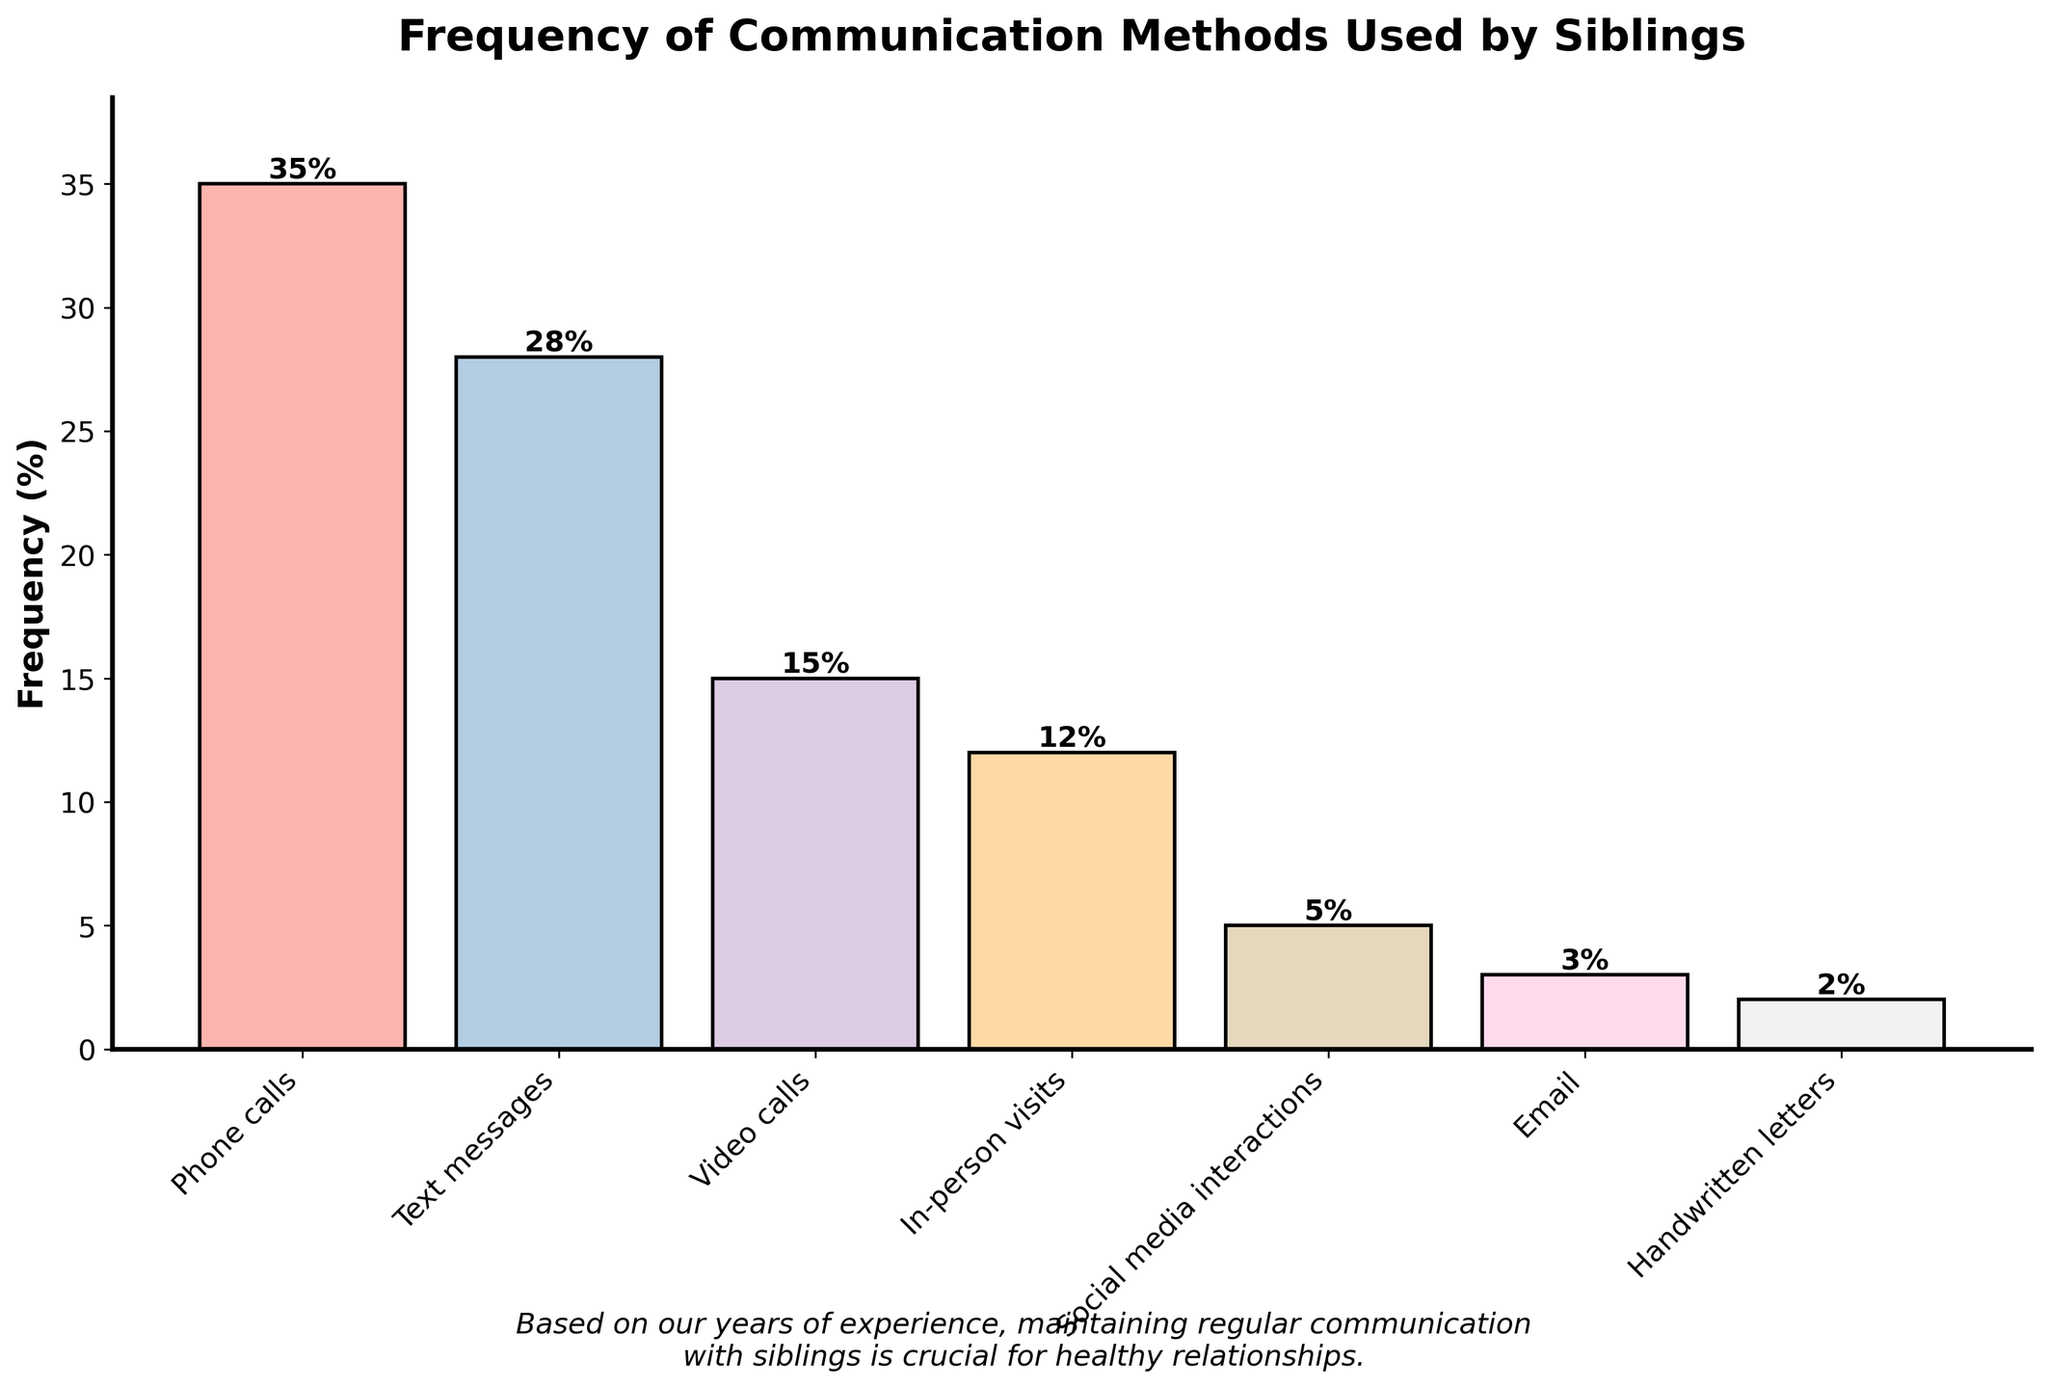What is the most frequently used communication method by siblings? The bar for "Phone calls" is the tallest, which indicates the highest frequency percentage.
Answer: Phone calls Which two communication methods combined account for more than 50% of the communication frequency? Adding the frequencies for "Phone calls" (35%) and "Text messages" (28%) equals 63%, which is more than half.
Answer: Phone calls and Text messages What is the difference in frequency between the most and least used communication methods? The most used is "Phone calls" at 35%, and the least used is "Handwritten letters" at 2%. The difference is 35% - 2% = 33%.
Answer: 33% How does the frequency of video calls compare to that of in-person visits? The bar for "Video calls" has a height of 15%, and the bar for "In-person visits" has a height of 12%. Video calls are more frequent.
Answer: Video calls are more frequent by 3% What is the average frequency of the top three communication methods? The top three are "Phone calls" (35%), "Text messages" (28%), and "Video calls" (15%). The average is (35 + 28 + 15) / 3 = 78 / 3 = 26%.
Answer: 26% Are social media interactions more or less frequent than email? The bar for "Social media interactions" is at 5%, and the bar for "Email" is at 3%. Social media interactions are more frequent.
Answer: More frequent What percentage of communication methods have a frequency less than 10%? Only "Social media interactions" (5%), "Email" (3%), and "Handwritten letters" (2%) are below 10%. This totals 3 methods out of 7. (3/7) * 100 = ~42.86%.
Answer: ~42.86% How much more frequent are in-person visits compared to handwritten letters? In-person visits are at 12%, while handwritten letters are at 2%. The difference is 12% - 2% = 10%.
Answer: 10% Which communication method has a frequency closest to the median value of all methods? Ordering the frequencies: [2, 3, 5, 12, 15, 28, 35], the median is 12%. This is the frequency for "In-person visits".
Answer: In-person visits 